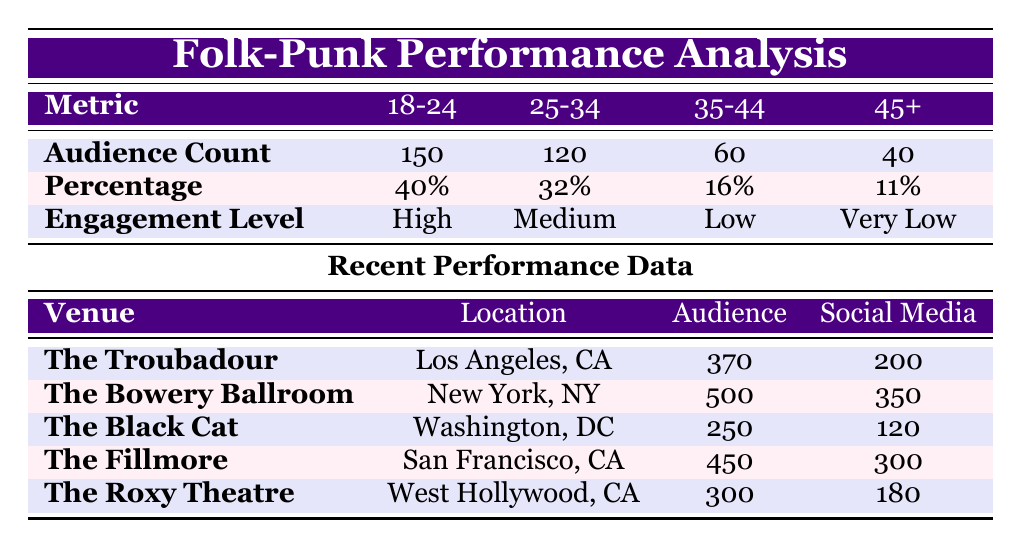What is the total audience count in the age group 18-24? The table shows the audience count for the age group 18-24 as 150.
Answer: 150 Which venue had the highest total audience? By comparing the total audience count for each venue, The Bowery Ballroom had the highest total audience of 500.
Answer: 500 How many total audience members were in the 35-44 age group? The table lists the audience count for the age group 35-44 as 60.
Answer: 60 What is the percentage of audience members aged 45-54? According to the table, the percentage of audience members aged 45-54 is 8%.
Answer: 8% Did The Black Cat have more social media interactions than The Roxy Theatre? The Black Cat had 120 social media interactions while The Roxy Theatre had 180. Since 120 is less than 180, the statement is false.
Answer: No What is the total audience count across all age groups? To find the total audience count, we sum the counts: 150 + 120 + 60 + 30 + 10 = 370.
Answer: 370 What percentage of the audience engaged at a high level? The only age group with high engagement is 18-24, which accounts for 40% of the total audience.
Answer: 40% Which age group shows the lowest engagement level? The age group 55+ has the engagement level listed as very low.
Answer: 55+ What is the average number of social media interactions for the venues listed? The total number of social media interactions across all venues is 200 + 350 + 120 + 300 + 180 = 1150. There are 5 venues, so the average is 1150 / 5 = 230.
Answer: 230 